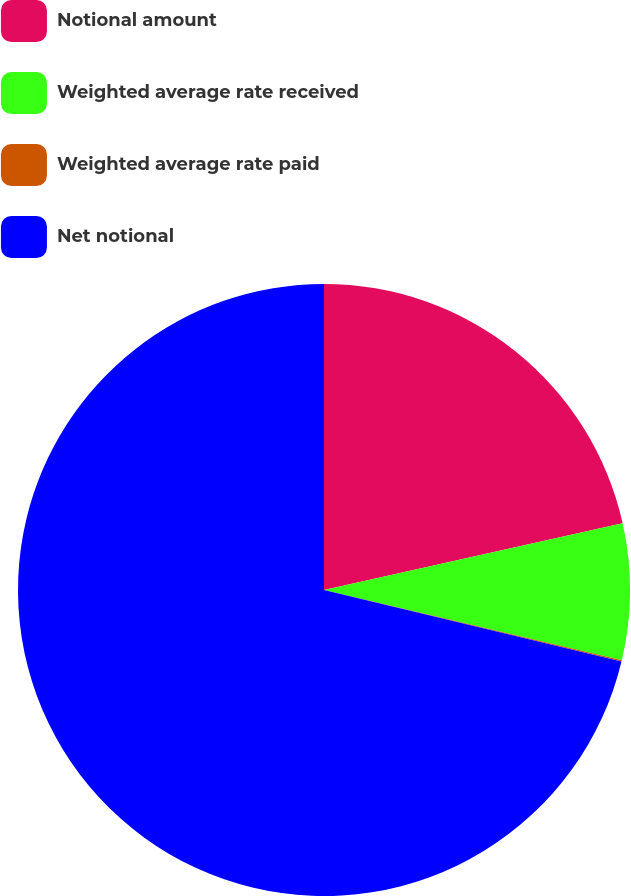Convert chart. <chart><loc_0><loc_0><loc_500><loc_500><pie_chart><fcel>Notional amount<fcel>Weighted average rate received<fcel>Weighted average rate paid<fcel>Net notional<nl><fcel>21.5%<fcel>7.19%<fcel>0.07%<fcel>71.24%<nl></chart> 